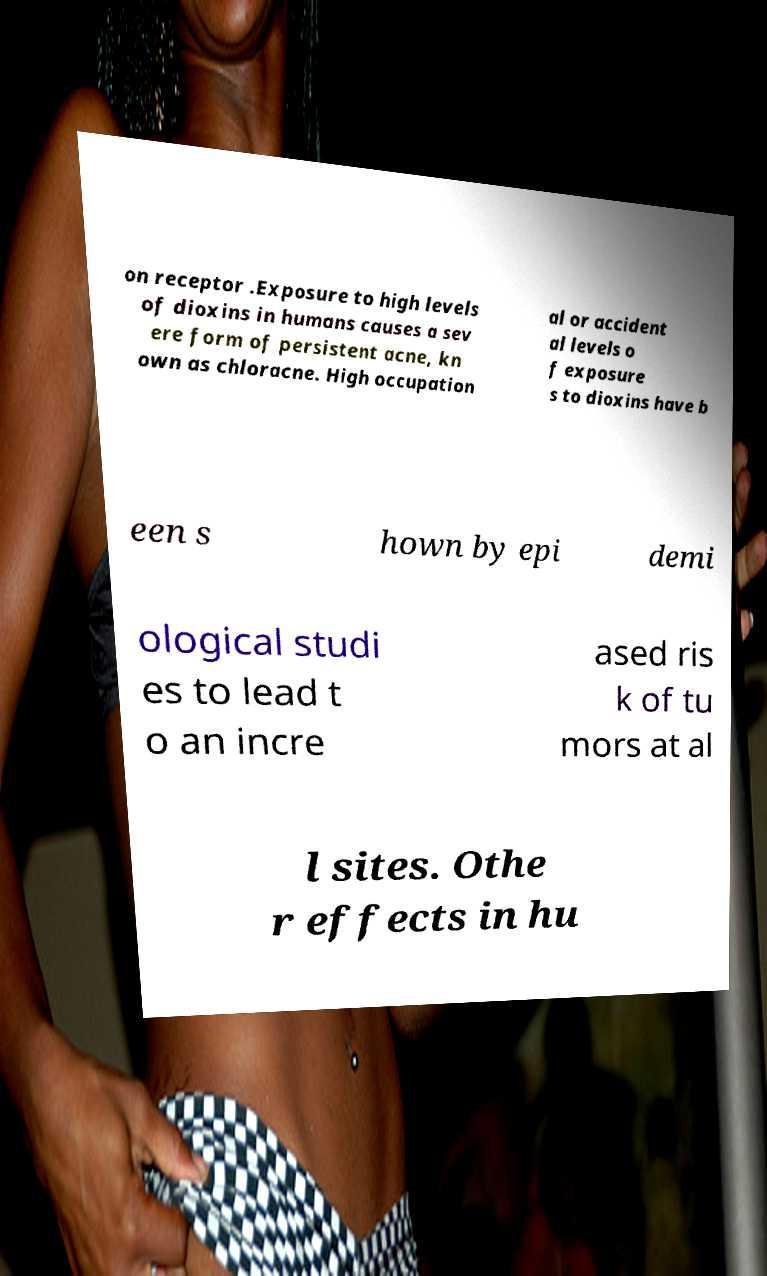Please read and relay the text visible in this image. What does it say? on receptor .Exposure to high levels of dioxins in humans causes a sev ere form of persistent acne, kn own as chloracne. High occupation al or accident al levels o f exposure s to dioxins have b een s hown by epi demi ological studi es to lead t o an incre ased ris k of tu mors at al l sites. Othe r effects in hu 